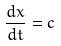<formula> <loc_0><loc_0><loc_500><loc_500>\frac { d x } { d t } = c</formula> 